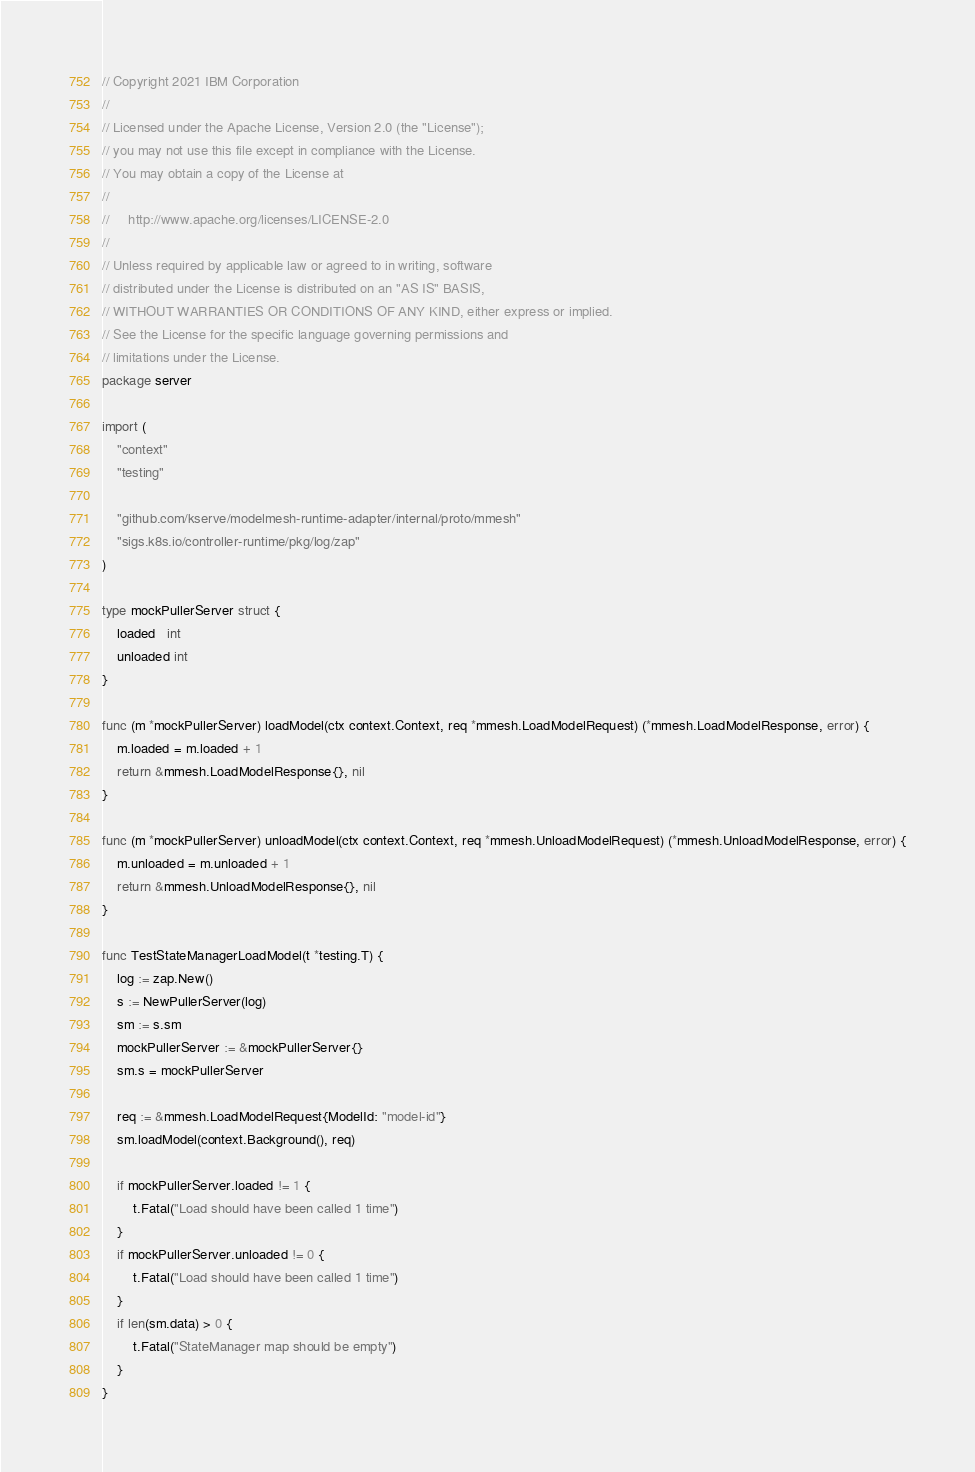<code> <loc_0><loc_0><loc_500><loc_500><_Go_>// Copyright 2021 IBM Corporation
//
// Licensed under the Apache License, Version 2.0 (the "License");
// you may not use this file except in compliance with the License.
// You may obtain a copy of the License at
//
//     http://www.apache.org/licenses/LICENSE-2.0
//
// Unless required by applicable law or agreed to in writing, software
// distributed under the License is distributed on an "AS IS" BASIS,
// WITHOUT WARRANTIES OR CONDITIONS OF ANY KIND, either express or implied.
// See the License for the specific language governing permissions and
// limitations under the License.
package server

import (
	"context"
	"testing"

	"github.com/kserve/modelmesh-runtime-adapter/internal/proto/mmesh"
	"sigs.k8s.io/controller-runtime/pkg/log/zap"
)

type mockPullerServer struct {
	loaded   int
	unloaded int
}

func (m *mockPullerServer) loadModel(ctx context.Context, req *mmesh.LoadModelRequest) (*mmesh.LoadModelResponse, error) {
	m.loaded = m.loaded + 1
	return &mmesh.LoadModelResponse{}, nil
}

func (m *mockPullerServer) unloadModel(ctx context.Context, req *mmesh.UnloadModelRequest) (*mmesh.UnloadModelResponse, error) {
	m.unloaded = m.unloaded + 1
	return &mmesh.UnloadModelResponse{}, nil
}

func TestStateManagerLoadModel(t *testing.T) {
	log := zap.New()
	s := NewPullerServer(log)
	sm := s.sm
	mockPullerServer := &mockPullerServer{}
	sm.s = mockPullerServer

	req := &mmesh.LoadModelRequest{ModelId: "model-id"}
	sm.loadModel(context.Background(), req)

	if mockPullerServer.loaded != 1 {
		t.Fatal("Load should have been called 1 time")
	}
	if mockPullerServer.unloaded != 0 {
		t.Fatal("Load should have been called 1 time")
	}
	if len(sm.data) > 0 {
		t.Fatal("StateManager map should be empty")
	}
}
</code> 